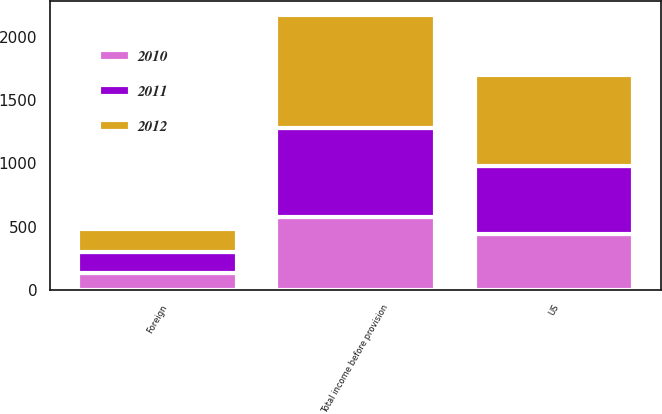Convert chart to OTSL. <chart><loc_0><loc_0><loc_500><loc_500><stacked_bar_chart><ecel><fcel>US<fcel>Foreign<fcel>Total income before provision<nl><fcel>2012<fcel>718.5<fcel>175.4<fcel>893.9<nl><fcel>2011<fcel>540.3<fcel>169.4<fcel>709.7<nl><fcel>2010<fcel>438.7<fcel>133.6<fcel>572.3<nl></chart> 